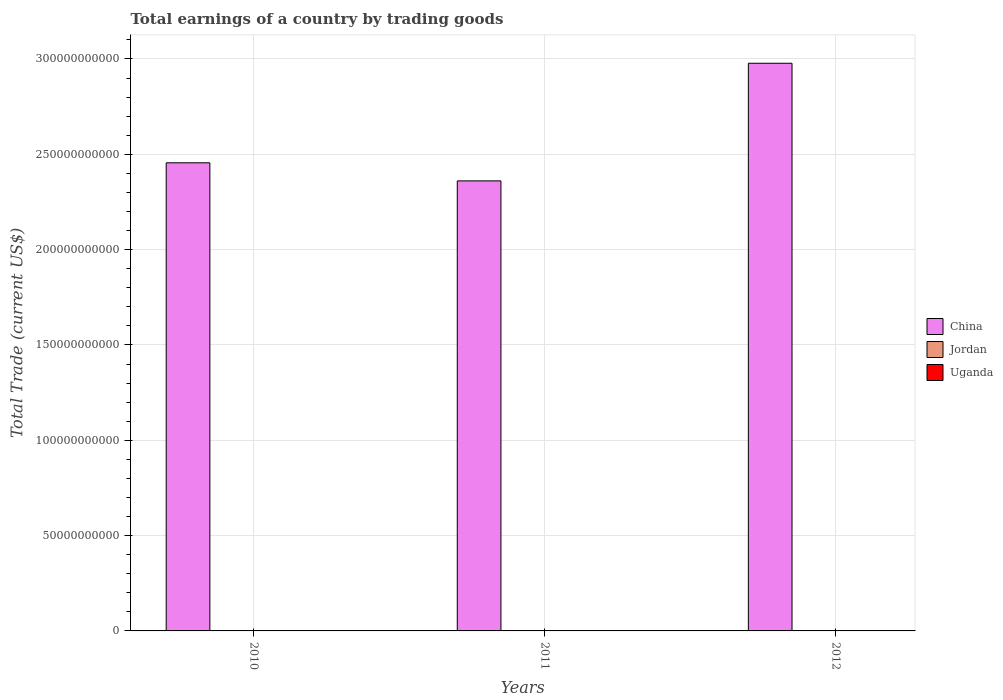Are the number of bars on each tick of the X-axis equal?
Provide a succinct answer. Yes. How many bars are there on the 3rd tick from the right?
Keep it short and to the point. 1. Across all years, what is the maximum total earnings in China?
Provide a short and direct response. 2.98e+11. In which year was the total earnings in China maximum?
Make the answer very short. 2012. What is the difference between the total earnings in China in 2010 and that in 2012?
Provide a short and direct response. -5.22e+1. What is the difference between the total earnings in Uganda in 2010 and the total earnings in China in 2012?
Your answer should be compact. -2.98e+11. In how many years, is the total earnings in Uganda greater than 40000000000 US$?
Give a very brief answer. 0. What is the ratio of the total earnings in China in 2011 to that in 2012?
Offer a terse response. 0.79. What is the difference between the highest and the lowest total earnings in China?
Offer a very short reply. 6.17e+1. How many bars are there?
Make the answer very short. 3. Are all the bars in the graph horizontal?
Make the answer very short. No. How many years are there in the graph?
Provide a succinct answer. 3. What is the difference between two consecutive major ticks on the Y-axis?
Provide a short and direct response. 5.00e+1. Are the values on the major ticks of Y-axis written in scientific E-notation?
Give a very brief answer. No. Does the graph contain any zero values?
Keep it short and to the point. Yes. Where does the legend appear in the graph?
Keep it short and to the point. Center right. How many legend labels are there?
Offer a very short reply. 3. How are the legend labels stacked?
Offer a terse response. Vertical. What is the title of the graph?
Keep it short and to the point. Total earnings of a country by trading goods. Does "Djibouti" appear as one of the legend labels in the graph?
Your answer should be compact. No. What is the label or title of the X-axis?
Your answer should be very brief. Years. What is the label or title of the Y-axis?
Give a very brief answer. Total Trade (current US$). What is the Total Trade (current US$) of China in 2010?
Provide a short and direct response. 2.46e+11. What is the Total Trade (current US$) of Jordan in 2010?
Ensure brevity in your answer.  0. What is the Total Trade (current US$) of China in 2011?
Your answer should be very brief. 2.36e+11. What is the Total Trade (current US$) of China in 2012?
Offer a terse response. 2.98e+11. What is the Total Trade (current US$) in Jordan in 2012?
Your answer should be very brief. 0. Across all years, what is the maximum Total Trade (current US$) of China?
Your answer should be compact. 2.98e+11. Across all years, what is the minimum Total Trade (current US$) of China?
Your answer should be very brief. 2.36e+11. What is the total Total Trade (current US$) in China in the graph?
Your answer should be compact. 7.79e+11. What is the total Total Trade (current US$) of Uganda in the graph?
Give a very brief answer. 0. What is the difference between the Total Trade (current US$) in China in 2010 and that in 2011?
Your response must be concise. 9.49e+09. What is the difference between the Total Trade (current US$) in China in 2010 and that in 2012?
Your answer should be very brief. -5.22e+1. What is the difference between the Total Trade (current US$) in China in 2011 and that in 2012?
Provide a short and direct response. -6.17e+1. What is the average Total Trade (current US$) in China per year?
Give a very brief answer. 2.60e+11. What is the ratio of the Total Trade (current US$) in China in 2010 to that in 2011?
Ensure brevity in your answer.  1.04. What is the ratio of the Total Trade (current US$) of China in 2010 to that in 2012?
Make the answer very short. 0.82. What is the ratio of the Total Trade (current US$) in China in 2011 to that in 2012?
Provide a succinct answer. 0.79. What is the difference between the highest and the second highest Total Trade (current US$) in China?
Your answer should be compact. 5.22e+1. What is the difference between the highest and the lowest Total Trade (current US$) of China?
Offer a terse response. 6.17e+1. 